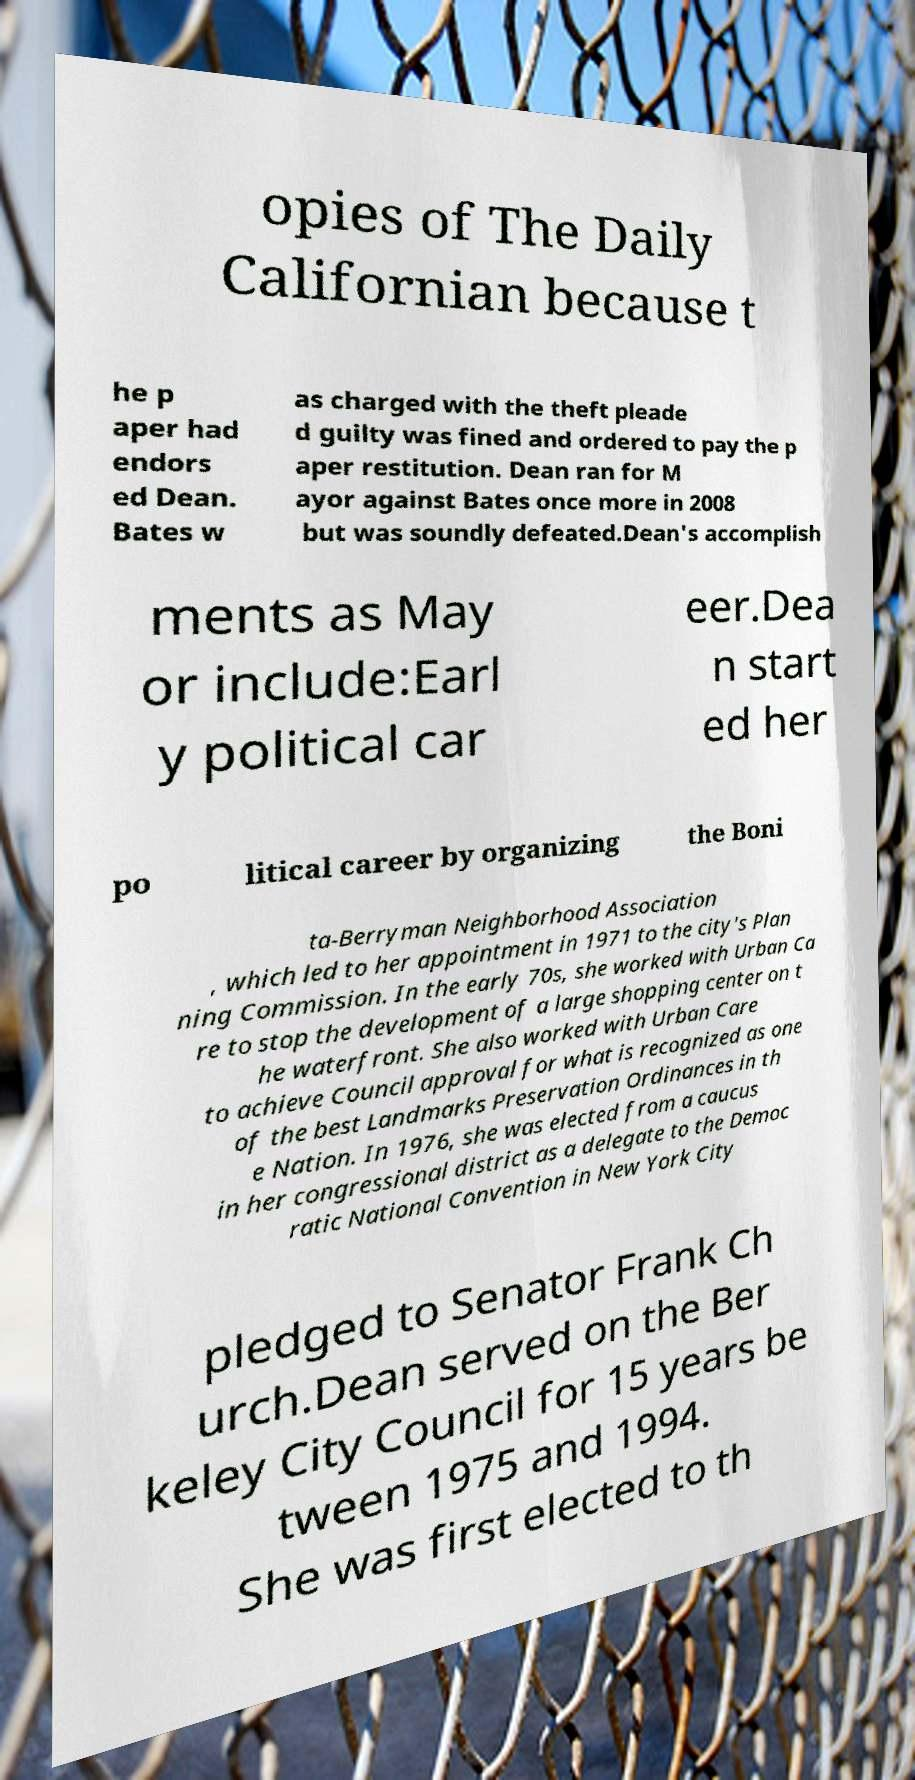There's text embedded in this image that I need extracted. Can you transcribe it verbatim? opies of The Daily Californian because t he p aper had endors ed Dean. Bates w as charged with the theft pleade d guilty was fined and ordered to pay the p aper restitution. Dean ran for M ayor against Bates once more in 2008 but was soundly defeated.Dean's accomplish ments as May or include:Earl y political car eer.Dea n start ed her po litical career by organizing the Boni ta-Berryman Neighborhood Association , which led to her appointment in 1971 to the city's Plan ning Commission. In the early 70s, she worked with Urban Ca re to stop the development of a large shopping center on t he waterfront. She also worked with Urban Care to achieve Council approval for what is recognized as one of the best Landmarks Preservation Ordinances in th e Nation. In 1976, she was elected from a caucus in her congressional district as a delegate to the Democ ratic National Convention in New York City pledged to Senator Frank Ch urch.Dean served on the Ber keley City Council for 15 years be tween 1975 and 1994. She was first elected to th 